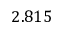Convert formula to latex. <formula><loc_0><loc_0><loc_500><loc_500>2 . 8 1 5</formula> 